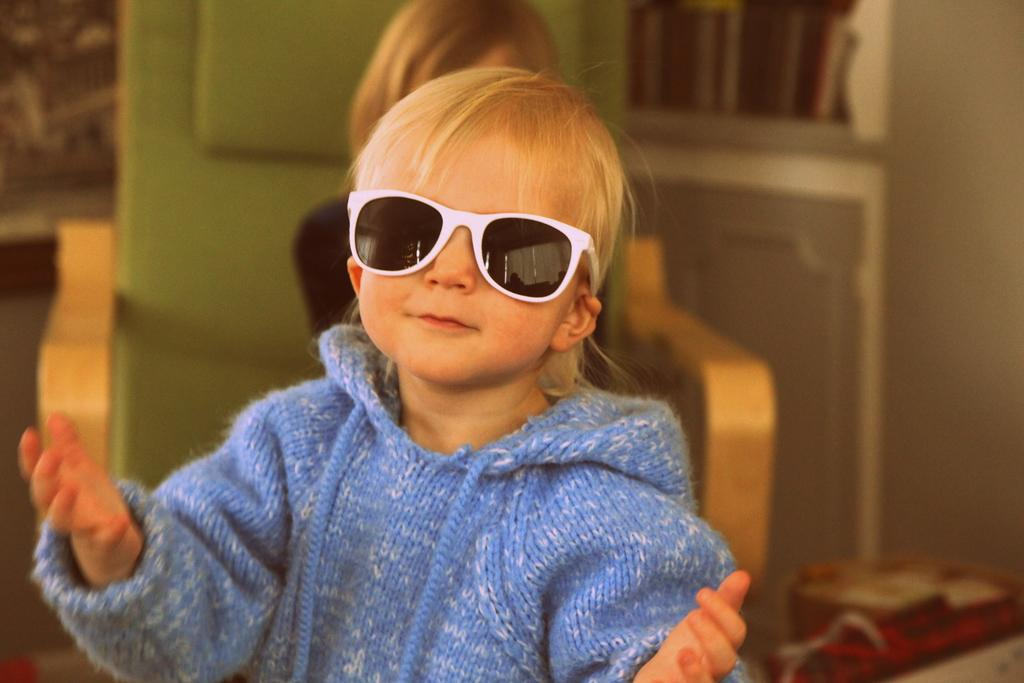What is the main subject of the image? There is a child in the image. Can you describe the child's appearance? The child is wearing glasses. What object is present in the image that can be used for sitting? There is a chair in the image. Who is sitting on the chair? There is a person sitting on the chair. What type of insect can be seen crawling on the cellar door in the image? There is no insect or cellar door present in the image. 